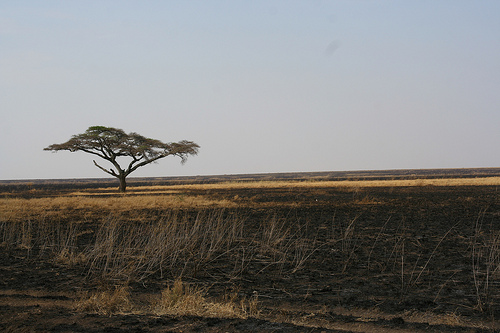<image>
Can you confirm if the tree is on the grass? No. The tree is not positioned on the grass. They may be near each other, but the tree is not supported by or resting on top of the grass. 